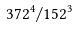Convert formula to latex. <formula><loc_0><loc_0><loc_500><loc_500>3 7 2 ^ { 4 } / 1 5 2 ^ { 3 }</formula> 